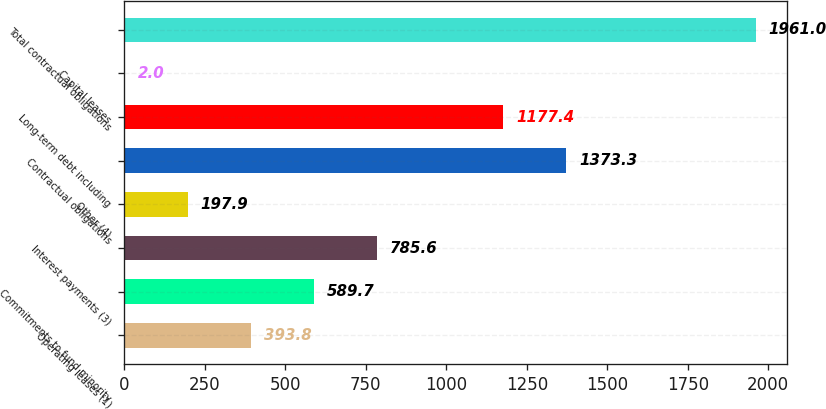Convert chart. <chart><loc_0><loc_0><loc_500><loc_500><bar_chart><fcel>Operating leases (1)<fcel>Commitments to fund minority<fcel>Interest payments (3)<fcel>Other (4)<fcel>Contractual obligations<fcel>Long-term debt including<fcel>Capital leases<fcel>Total contractual obligations<nl><fcel>393.8<fcel>589.7<fcel>785.6<fcel>197.9<fcel>1373.3<fcel>1177.4<fcel>2<fcel>1961<nl></chart> 